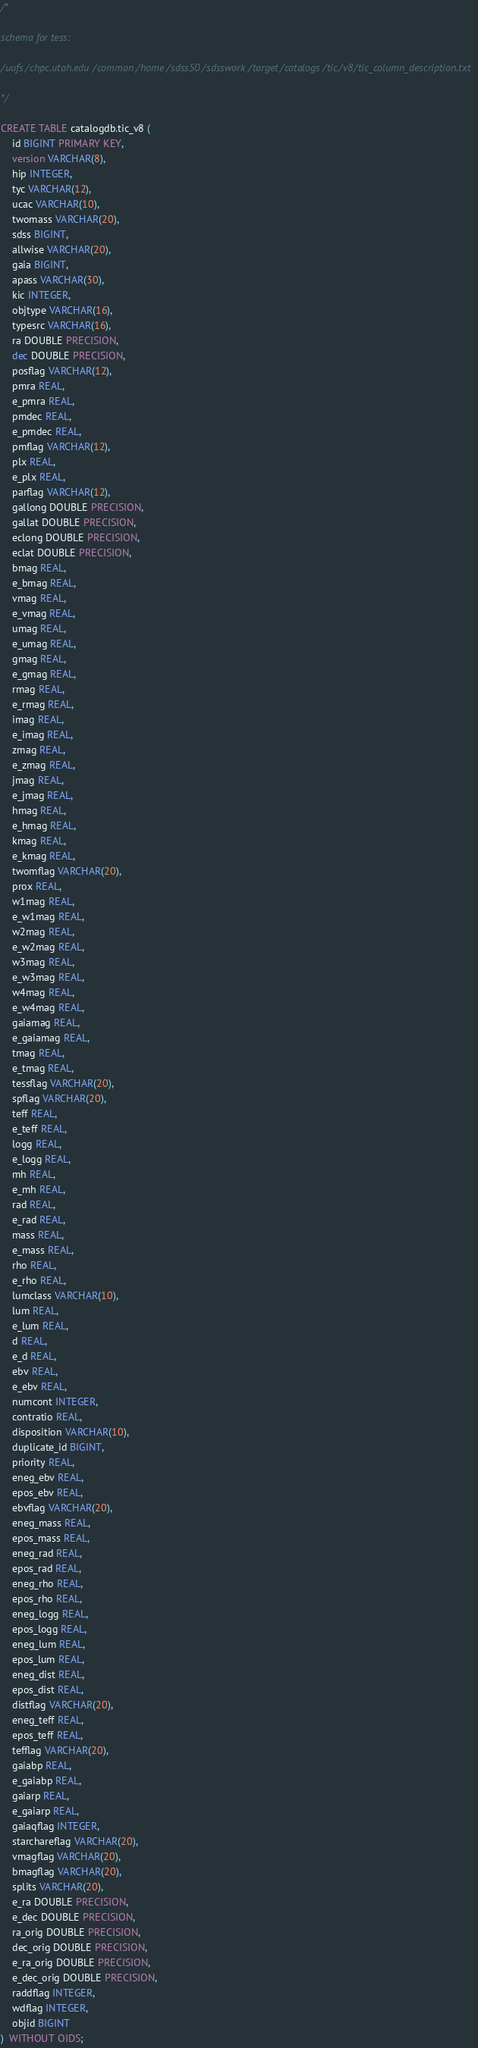Convert code to text. <code><loc_0><loc_0><loc_500><loc_500><_SQL_>/*

schema for tess:

/uufs/chpc.utah.edu/common/home/sdss50/sdsswork/target/catalogs/tic/v8/tic_column_description.txt

*/

CREATE TABLE catalogdb.tic_v8 (
	id BIGINT PRIMARY KEY,
	version VARCHAR(8),
	hip INTEGER,
	tyc VARCHAR(12),
	ucac VARCHAR(10),
	twomass VARCHAR(20),
	sdss BIGINT,
	allwise VARCHAR(20),
	gaia BIGINT,
	apass VARCHAR(30),
	kic INTEGER,
	objtype VARCHAR(16),
	typesrc VARCHAR(16),
	ra DOUBLE PRECISION,
	dec DOUBLE PRECISION,
	posflag VARCHAR(12),
	pmra REAL,
	e_pmra REAL,
	pmdec REAL,
	e_pmdec REAL,
	pmflag VARCHAR(12),
	plx REAL,
	e_plx REAL,
	parflag VARCHAR(12),
	gallong DOUBLE PRECISION,
	gallat DOUBLE PRECISION,
	eclong DOUBLE PRECISION,
	eclat DOUBLE PRECISION,
	bmag REAL,
	e_bmag REAL,
	vmag REAL,
	e_vmag REAL,
	umag REAL,
	e_umag REAL,
	gmag REAL,
	e_gmag REAL,
	rmag REAL,
	e_rmag REAL,
	imag REAL,
	e_imag REAL,
	zmag REAL,
	e_zmag REAL,
	jmag REAL,
	e_jmag REAL,
	hmag REAL,
	e_hmag REAL,
	kmag REAL,
	e_kmag REAL,
	twomflag VARCHAR(20),
	prox REAL,
	w1mag REAL,
	e_w1mag REAL,
	w2mag REAL,
	e_w2mag REAL,
	w3mag REAL,
	e_w3mag REAL,
	w4mag REAL,
	e_w4mag REAL,
	gaiamag REAL,
	e_gaiamag REAL,
	tmag REAL,
	e_tmag REAL,
	tessflag VARCHAR(20),
	spflag VARCHAR(20),
	teff REAL,
	e_teff REAL,
	logg REAL,
	e_logg REAL,
	mh REAL,
	e_mh REAL,
	rad REAL,
	e_rad REAL,
	mass REAL,
	e_mass REAL,
	rho REAL,
	e_rho REAL,
	lumclass VARCHAR(10),
	lum REAL,
	e_lum REAL,
	d REAL,
    e_d REAL,
	ebv REAL,
	e_ebv REAL,
	numcont INTEGER,
	contratio REAL,
	disposition VARCHAR(10),
	duplicate_id BIGINT,
	priority REAL,
	eneg_ebv REAL,
	epos_ebv REAL,
	ebvflag VARCHAR(20),
	eneg_mass REAL,
	epos_mass REAL,
	eneg_rad REAL,
	epos_rad REAL,
	eneg_rho REAL,
	epos_rho REAL,
	eneg_logg REAL,
	epos_logg REAL,
	eneg_lum REAL,
	epos_lum REAL,
	eneg_dist REAL,
	epos_dist REAL,
	distflag VARCHAR(20),
	eneg_teff REAL,
	epos_teff REAL,
	tefflag VARCHAR(20),
	gaiabp REAL,
	e_gaiabp REAL,
	gaiarp REAL,
	e_gaiarp REAL,
	gaiaqflag INTEGER,
	starchareflag VARCHAR(20),
	vmagflag VARCHAR(20),
	bmagflag VARCHAR(20),
	splits VARCHAR(20),
	e_ra DOUBLE PRECISION,
	e_dec DOUBLE PRECISION,
	ra_orig DOUBLE PRECISION,
	dec_orig DOUBLE PRECISION,
	e_ra_orig DOUBLE PRECISION,
	e_dec_orig DOUBLE PRECISION,
	raddflag INTEGER,
	wdflag INTEGER,
	objid BIGINT
)  WITHOUT OIDS;
</code> 